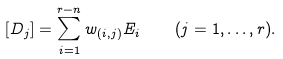Convert formula to latex. <formula><loc_0><loc_0><loc_500><loc_500>[ D _ { j } ] = \sum _ { i = 1 } ^ { r - n } w _ { ( i , j ) } E _ { i } \quad ( j = 1 , \dots , r ) .</formula> 